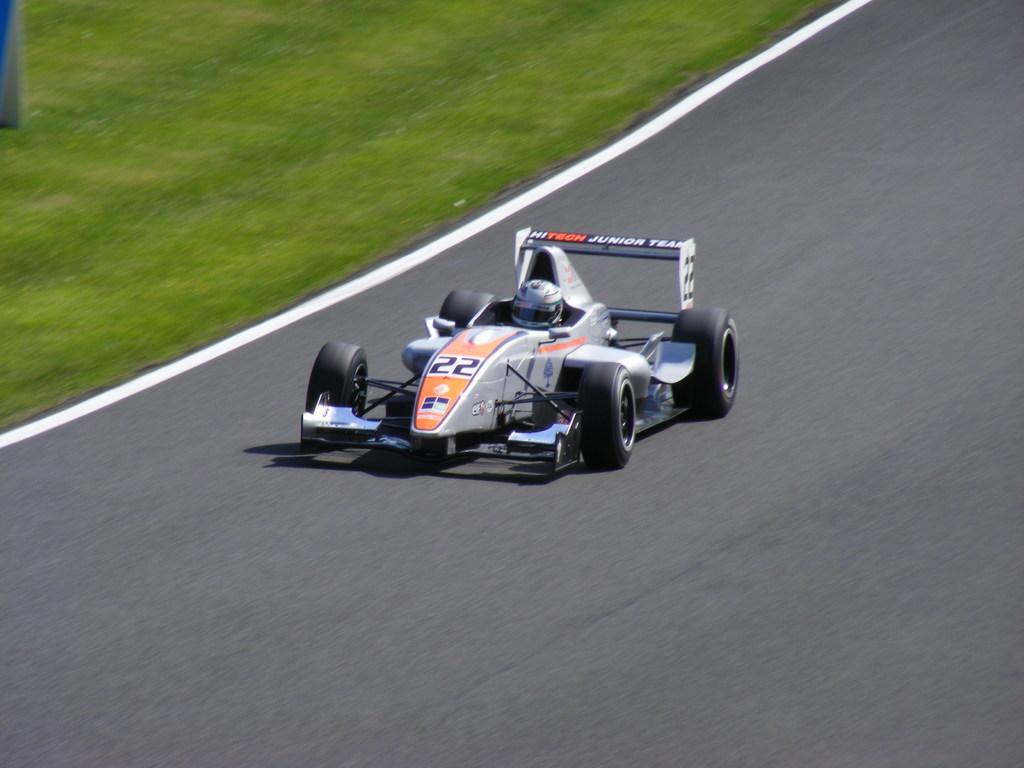Please provide a concise description of this image. In this image there is a vehicle on the road. A person is sitting in the vehicle. He is wearing a helmet. Left top there is grassland. 